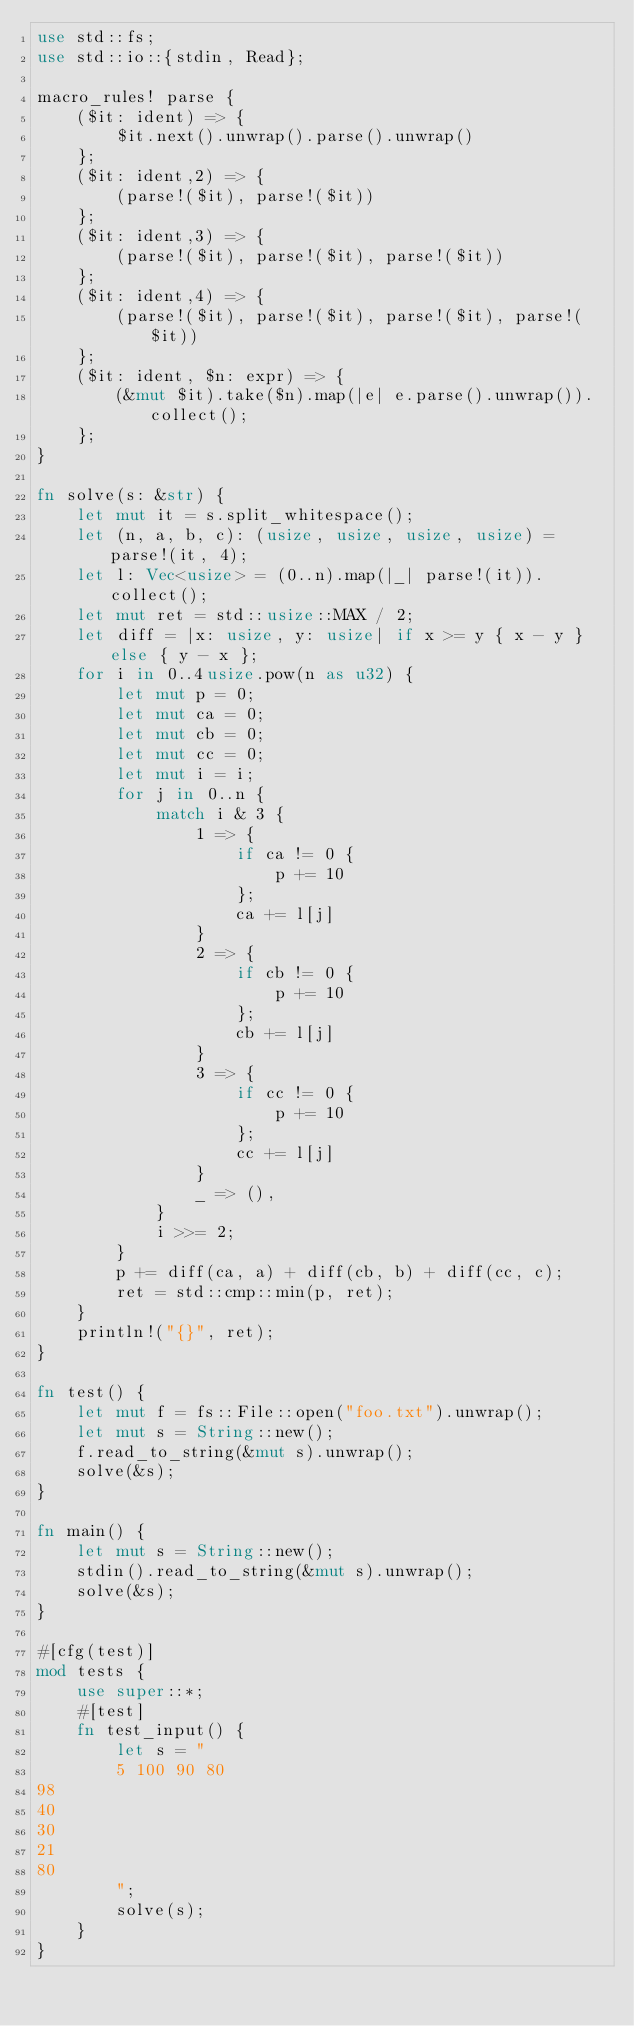Convert code to text. <code><loc_0><loc_0><loc_500><loc_500><_Rust_>use std::fs;
use std::io::{stdin, Read};

macro_rules! parse {
    ($it: ident) => {
        $it.next().unwrap().parse().unwrap()
    };
    ($it: ident,2) => {
        (parse!($it), parse!($it))
    };
    ($it: ident,3) => {
        (parse!($it), parse!($it), parse!($it))
    };
    ($it: ident,4) => {
        (parse!($it), parse!($it), parse!($it), parse!($it))
    };
    ($it: ident, $n: expr) => {
        (&mut $it).take($n).map(|e| e.parse().unwrap()).collect();
    };
}

fn solve(s: &str) {
    let mut it = s.split_whitespace();
    let (n, a, b, c): (usize, usize, usize, usize) = parse!(it, 4);
    let l: Vec<usize> = (0..n).map(|_| parse!(it)).collect();
    let mut ret = std::usize::MAX / 2;
    let diff = |x: usize, y: usize| if x >= y { x - y } else { y - x };
    for i in 0..4usize.pow(n as u32) {
        let mut p = 0;
        let mut ca = 0;
        let mut cb = 0;
        let mut cc = 0;
        let mut i = i;
        for j in 0..n {
            match i & 3 {
                1 => {
                    if ca != 0 {
                        p += 10
                    };
                    ca += l[j]
                }
                2 => {
                    if cb != 0 {
                        p += 10
                    };
                    cb += l[j]
                }
                3 => {
                    if cc != 0 {
                        p += 10
                    };
                    cc += l[j]
                }
                _ => (),
            }
            i >>= 2;
        }
        p += diff(ca, a) + diff(cb, b) + diff(cc, c);
        ret = std::cmp::min(p, ret);
    }
    println!("{}", ret);
}

fn test() {
    let mut f = fs::File::open("foo.txt").unwrap();
    let mut s = String::new();
    f.read_to_string(&mut s).unwrap();
    solve(&s);
}

fn main() {
    let mut s = String::new();
    stdin().read_to_string(&mut s).unwrap();
    solve(&s);
}

#[cfg(test)]
mod tests {
    use super::*;
    #[test]
    fn test_input() {
        let s = "
        5 100 90 80
98
40
30
21
80
        ";
        solve(s);
    }
}
</code> 